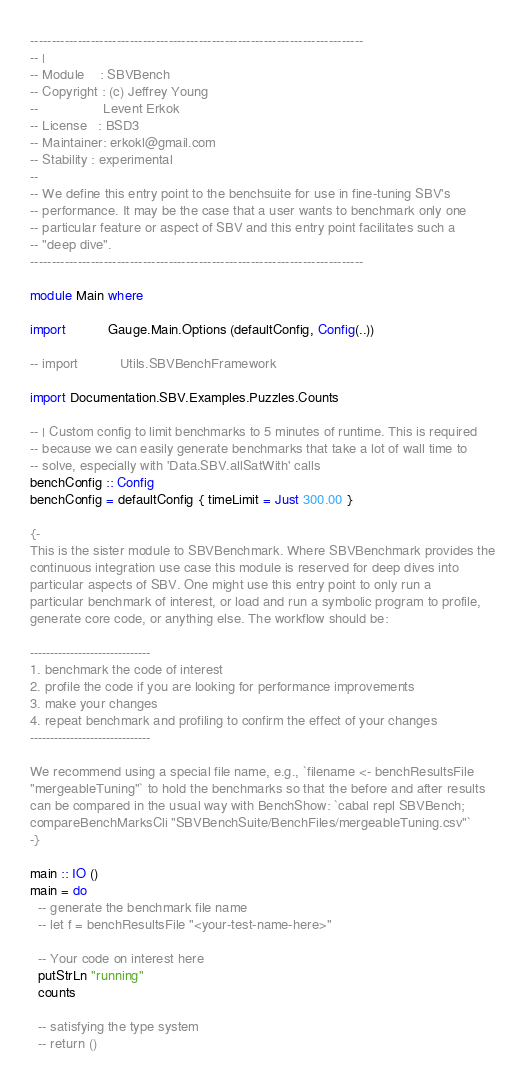<code> <loc_0><loc_0><loc_500><loc_500><_Haskell_>-----------------------------------------------------------------------------
-- |
-- Module    : SBVBench
-- Copyright : (c) Jeffrey Young
--                 Levent Erkok
-- License   : BSD3
-- Maintainer: erkokl@gmail.com
-- Stability : experimental
--
-- We define this entry point to the benchsuite for use in fine-tuning SBV's
-- performance. It may be the case that a user wants to benchmark only one
-- particular feature or aspect of SBV and this entry point facilitates such a
-- "deep dive".
-----------------------------------------------------------------------------

module Main where

import           Gauge.Main.Options (defaultConfig, Config(..))

-- import           Utils.SBVBenchFramework

import Documentation.SBV.Examples.Puzzles.Counts

-- | Custom config to limit benchmarks to 5 minutes of runtime. This is required
-- because we can easily generate benchmarks that take a lot of wall time to
-- solve, especially with 'Data.SBV.allSatWith' calls
benchConfig :: Config
benchConfig = defaultConfig { timeLimit = Just 300.00 }

{-
This is the sister module to SBVBenchmark. Where SBVBenchmark provides the
continuous integration use case this module is reserved for deep dives into
particular aspects of SBV. One might use this entry point to only run a
particular benchmark of interest, or load and run a symbolic program to profile,
generate core code, or anything else. The workflow should be:

------------------------------
1. benchmark the code of interest
2. profile the code if you are looking for performance improvements
3. make your changes
4. repeat benchmark and profiling to confirm the effect of your changes
------------------------------

We recommend using a special file name, e.g., `filename <- benchResultsFile
"mergeableTuning"` to hold the benchmarks so that the before and after results
can be compared in the usual way with BenchShow: `cabal repl SBVBench;
compareBenchMarksCli "SBVBenchSuite/BenchFiles/mergeableTuning.csv"`
-}

main :: IO ()
main = do
  -- generate the benchmark file name
  -- let f = benchResultsFile "<your-test-name-here>"

  -- Your code on interest here
  putStrLn "running"
  counts

  -- satisfying the type system
  -- return ()
</code> 